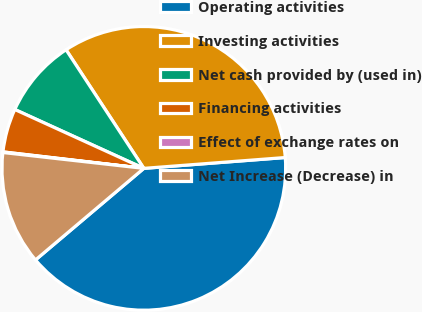Convert chart. <chart><loc_0><loc_0><loc_500><loc_500><pie_chart><fcel>Operating activities<fcel>Investing activities<fcel>Net cash provided by (used in)<fcel>Financing activities<fcel>Effect of exchange rates on<fcel>Net Increase (Decrease) in<nl><fcel>40.05%<fcel>33.02%<fcel>8.95%<fcel>4.96%<fcel>0.07%<fcel>12.95%<nl></chart> 